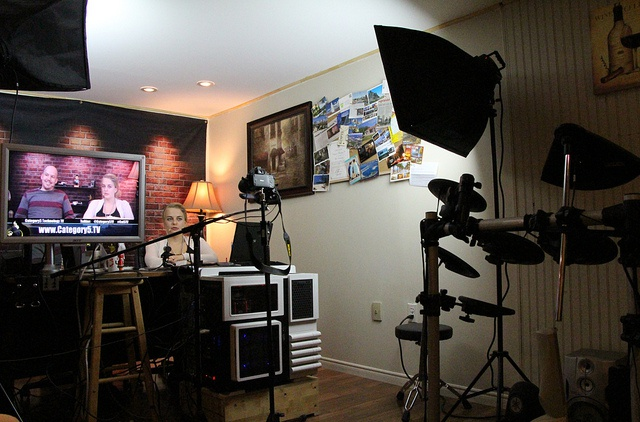Describe the objects in this image and their specific colors. I can see tv in black, gray, lavender, and violet tones, people in black, darkgray, tan, and gray tones, people in black, gray, violet, and purple tones, people in black, lavender, pink, lightpink, and darkgray tones, and laptop in black and gray tones in this image. 